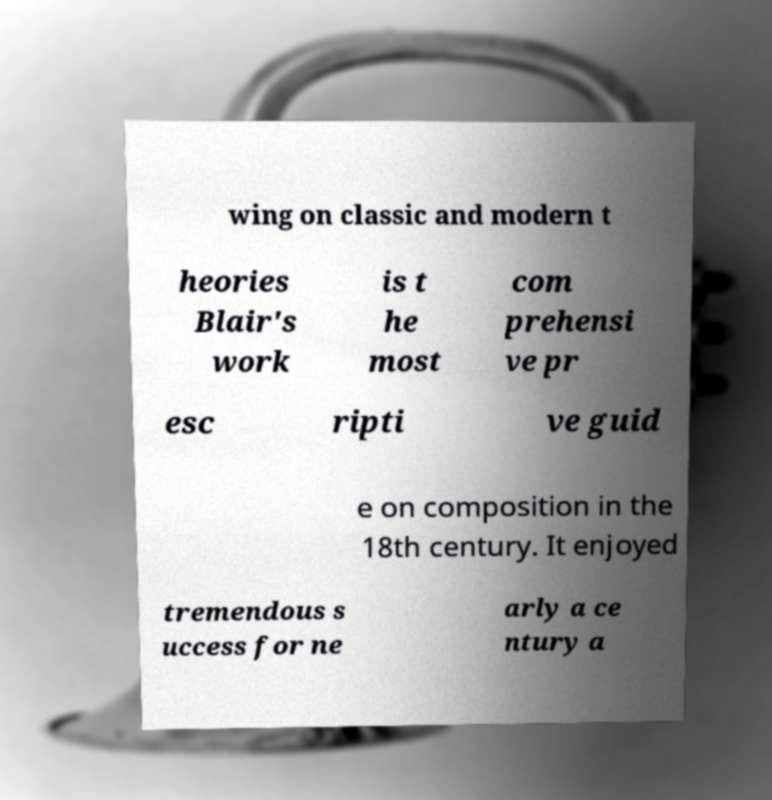What messages or text are displayed in this image? I need them in a readable, typed format. wing on classic and modern t heories Blair's work is t he most com prehensi ve pr esc ripti ve guid e on composition in the 18th century. It enjoyed tremendous s uccess for ne arly a ce ntury a 